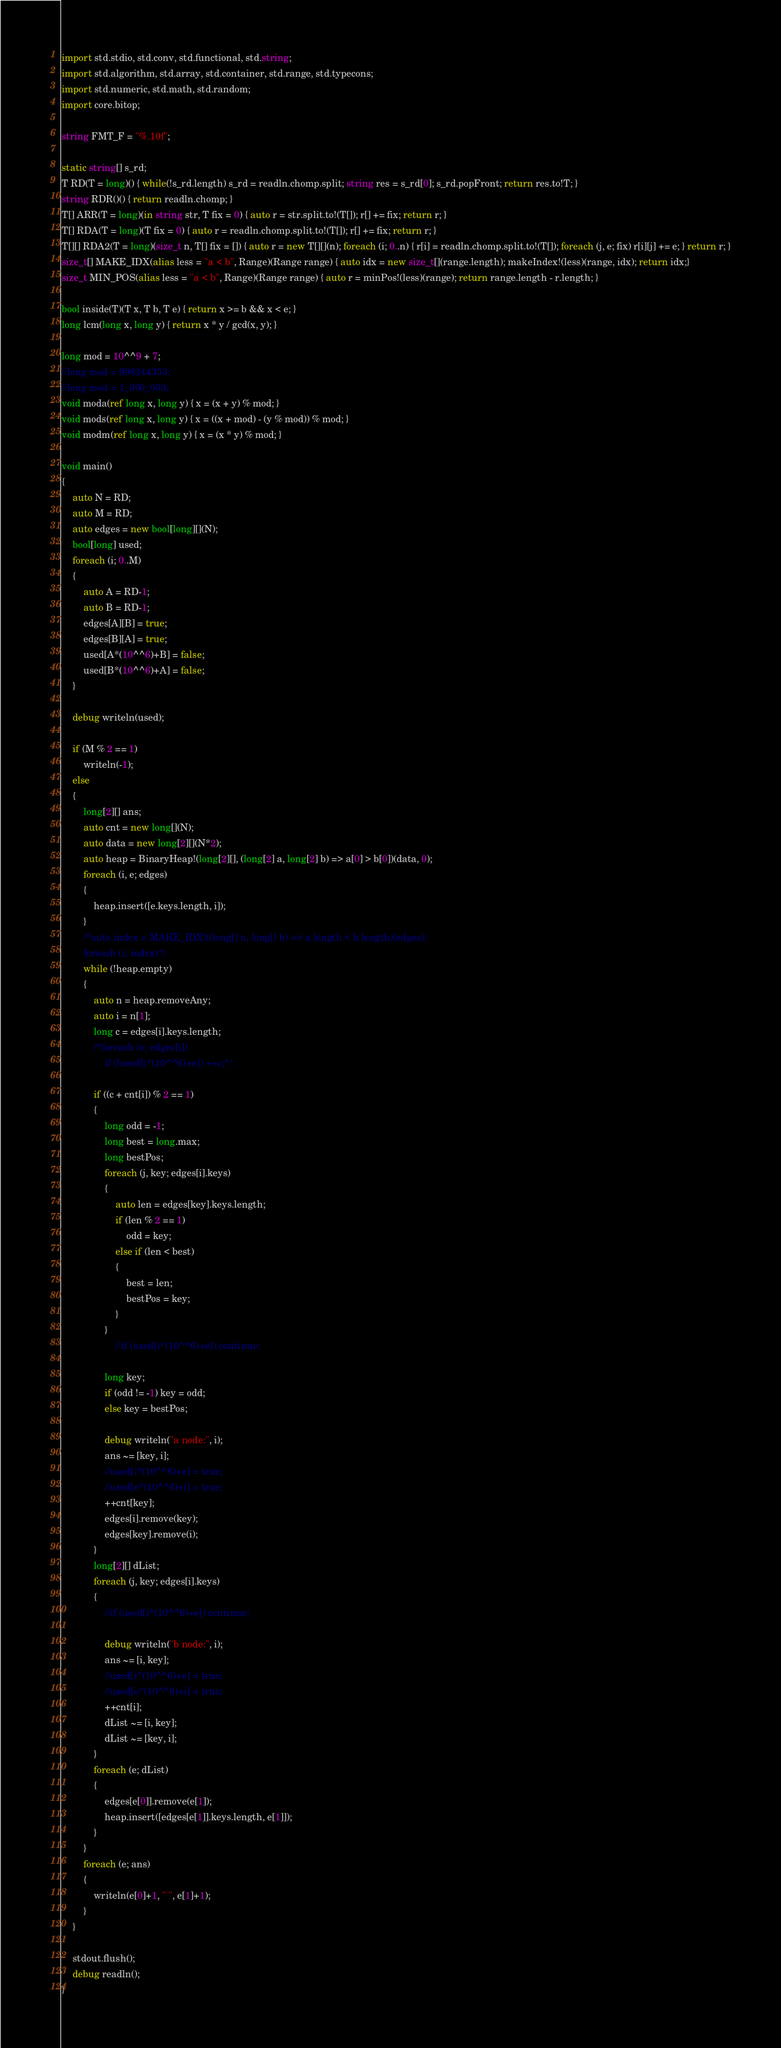<code> <loc_0><loc_0><loc_500><loc_500><_D_>import std.stdio, std.conv, std.functional, std.string;
import std.algorithm, std.array, std.container, std.range, std.typecons;
import std.numeric, std.math, std.random;
import core.bitop;

string FMT_F = "%.10f";

static string[] s_rd;
T RD(T = long)() { while(!s_rd.length) s_rd = readln.chomp.split; string res = s_rd[0]; s_rd.popFront; return res.to!T; }
string RDR()() { return readln.chomp; }
T[] ARR(T = long)(in string str, T fix = 0) { auto r = str.split.to!(T[]); r[] += fix; return r; }
T[] RDA(T = long)(T fix = 0) { auto r = readln.chomp.split.to!(T[]); r[] += fix; return r; }
T[][] RDA2(T = long)(size_t n, T[] fix = []) { auto r = new T[][](n); foreach (i; 0..n) { r[i] = readln.chomp.split.to!(T[]); foreach (j, e; fix) r[i][j] += e; } return r; }
size_t[] MAKE_IDX(alias less = "a < b", Range)(Range range) { auto idx = new size_t[](range.length); makeIndex!(less)(range, idx); return idx;}
size_t MIN_POS(alias less = "a < b", Range)(Range range) { auto r = minPos!(less)(range); return range.length - r.length; }

bool inside(T)(T x, T b, T e) { return x >= b && x < e; }
long lcm(long x, long y) { return x * y / gcd(x, y); }

long mod = 10^^9 + 7;
//long mod = 998244353;
//long mod = 1_000_003;
void moda(ref long x, long y) { x = (x + y) % mod; }
void mods(ref long x, long y) { x = ((x + mod) - (y % mod)) % mod; }
void modm(ref long x, long y) { x = (x * y) % mod; }

void main()
{
	auto N = RD;
	auto M = RD;
	auto edges = new bool[long][](N);
	bool[long] used;
	foreach (i; 0..M)
	{
		auto A = RD-1;
		auto B = RD-1;
		edges[A][B] = true;
		edges[B][A] = true;
		used[A*(10^^6)+B] = false;
		used[B*(10^^6)+A] = false;
	}

	debug writeln(used);

	if (M % 2 == 1)
		writeln(-1);
	else
	{
		long[2][] ans;
		auto cnt = new long[](N);
		auto data = new long[2][](N*2);
		auto heap = BinaryHeap!(long[2][], (long[2] a, long[2] b) => a[0] > b[0])(data, 0);
		foreach (i, e; edges)
		{
			heap.insert([e.keys.length, i]);
		}
		/*auto index = MAKE_IDX!((long[] a, long[] b) => a.length < b.length)(edges);
		foreach (i; index)*/
		while (!heap.empty)
		{
			auto n = heap.removeAny;
			auto i = n[1];
			long c = edges[i].keys.length;
			/*foreach (e; edges[i])
				if (!used[i*(10^^6)+e]) ++c;*/

			if ((c + cnt[i]) % 2 == 1)
			{
				long odd = -1;
				long best = long.max;
				long bestPos;
				foreach (j, key; edges[i].keys)
				{
					auto len = edges[key].keys.length;
					if (len % 2 == 1)
						odd = key;
					else if (len < best)
					{
						best = len;
						bestPos = key;
					}
				}
					//if (used[i*(10^^6)+e]) continue;

				long key;
				if (odd != -1) key = odd;
				else key = bestPos;

				debug writeln("a node:", i);
				ans ~= [key, i];
				//used[i*(10^^6)+e] = true;
				//used[e*(10^^6)+i] = true;
				++cnt[key];
				edges[i].remove(key);
				edges[key].remove(i);
			}
			long[2][] dList;
			foreach (j, key; edges[i].keys)
			{
				//if (used[i*(10^^6)+e]) continue;

				debug writeln("b node:", i);
				ans ~= [i, key];
				//used[i*(10^^6)+e] = true;
				//used[e*(10^^6)+i] = true;
				++cnt[i];
				dList ~= [i, key];
				dList ~= [key, i];
			}
			foreach (e; dList)
			{
				edges[e[0]].remove(e[1]);
				heap.insert([edges[e[1]].keys.length, e[1]]);
			}
		}
		foreach (e; ans)
		{
			writeln(e[0]+1, " ", e[1]+1);
		}
	}
	
	stdout.flush();
	debug readln();
}</code> 